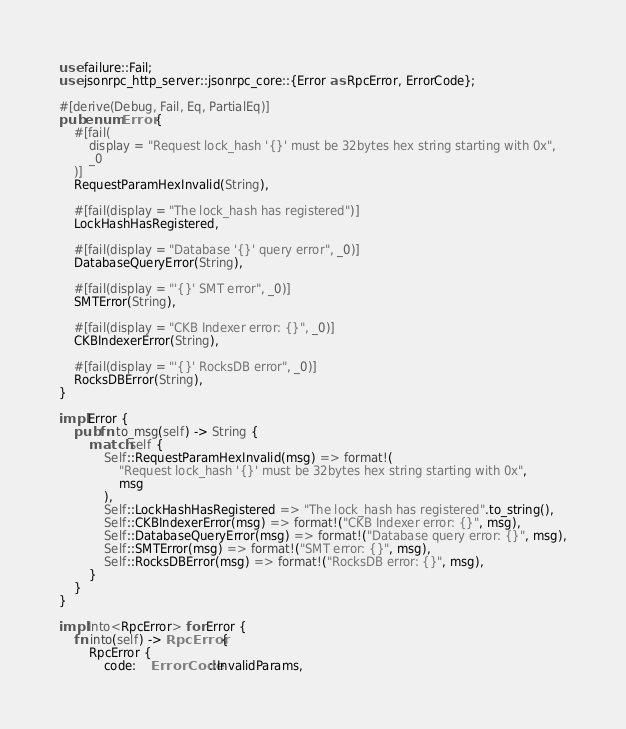<code> <loc_0><loc_0><loc_500><loc_500><_Rust_>use failure::Fail;
use jsonrpc_http_server::jsonrpc_core::{Error as RpcError, ErrorCode};

#[derive(Debug, Fail, Eq, PartialEq)]
pub enum Error {
    #[fail(
        display = "Request lock_hash '{}' must be 32bytes hex string starting with 0x",
        _0
    )]
    RequestParamHexInvalid(String),

    #[fail(display = "The lock_hash has registered")]
    LockHashHasRegistered,

    #[fail(display = "Database '{}' query error", _0)]
    DatabaseQueryError(String),

    #[fail(display = "'{}' SMT error", _0)]
    SMTError(String),

    #[fail(display = "CKB Indexer error: {}", _0)]
    CKBIndexerError(String),

    #[fail(display = "'{}' RocksDB error", _0)]
    RocksDBError(String),
}

impl Error {
    pub fn to_msg(self) -> String {
        match self {
            Self::RequestParamHexInvalid(msg) => format!(
                "Request lock_hash '{}' must be 32bytes hex string starting with 0x",
                msg
            ),
            Self::LockHashHasRegistered => "The lock_hash has registered".to_string(),
            Self::CKBIndexerError(msg) => format!("CKB Indexer error: {}", msg),
            Self::DatabaseQueryError(msg) => format!("Database query error: {}", msg),
            Self::SMTError(msg) => format!("SMT error: {}", msg),
            Self::RocksDBError(msg) => format!("RocksDB error: {}", msg),
        }
    }
}

impl Into<RpcError> for Error {
    fn into(self) -> RpcError {
        RpcError {
            code:    ErrorCode::InvalidParams,</code> 